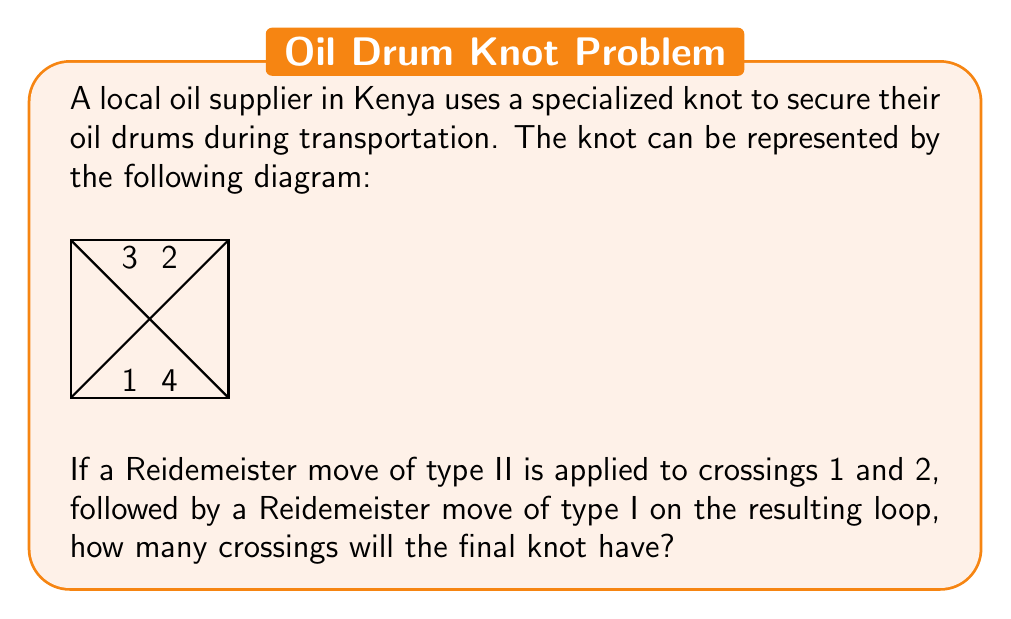What is the answer to this math problem? Let's approach this step-by-step:

1) First, we need to understand what Reidemeister moves are:
   - Type I: Adds or removes a twist in the knot
   - Type II: Adds or removes two crossings
   - Type III: Moves a strand from one side of a crossing to the other

2) The initial knot has 4 crossings, labeled 1, 2, 3, and 4.

3) Applying a Reidemeister move of type II to crossings 1 and 2:
   - This move will remove both crossings 1 and 2
   - The knot now has 2 crossings (3 and 4)

4) The removal of crossings 1 and 2 will create a loop in the knot.

5) Applying a Reidemeister move of type I to this loop:
   - This move will remove the loop entirely
   - No new crossings are added in this process

6) After both moves, we are left with a knot that has only 2 crossings (the original crossings 3 and 4).

Therefore, the final knot will have 2 crossings.
Answer: 2 crossings 